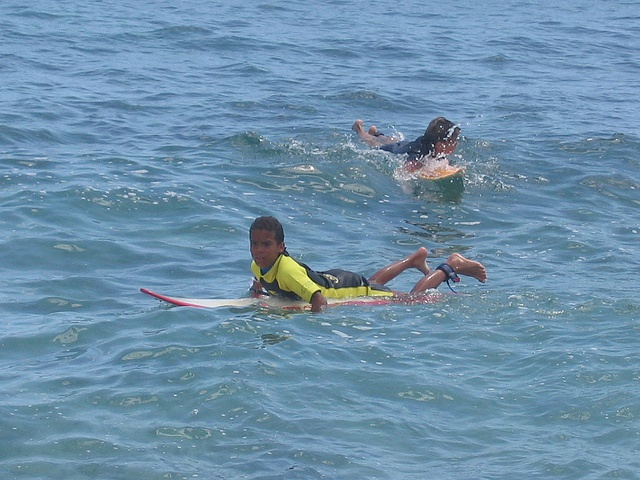Describe the objects in this image and their specific colors. I can see people in darkgray, gray, and olive tones, people in darkgray, gray, black, and darkblue tones, surfboard in darkgray, lightgray, and gray tones, and surfboard in darkgray, tan, lightgray, and gray tones in this image. 